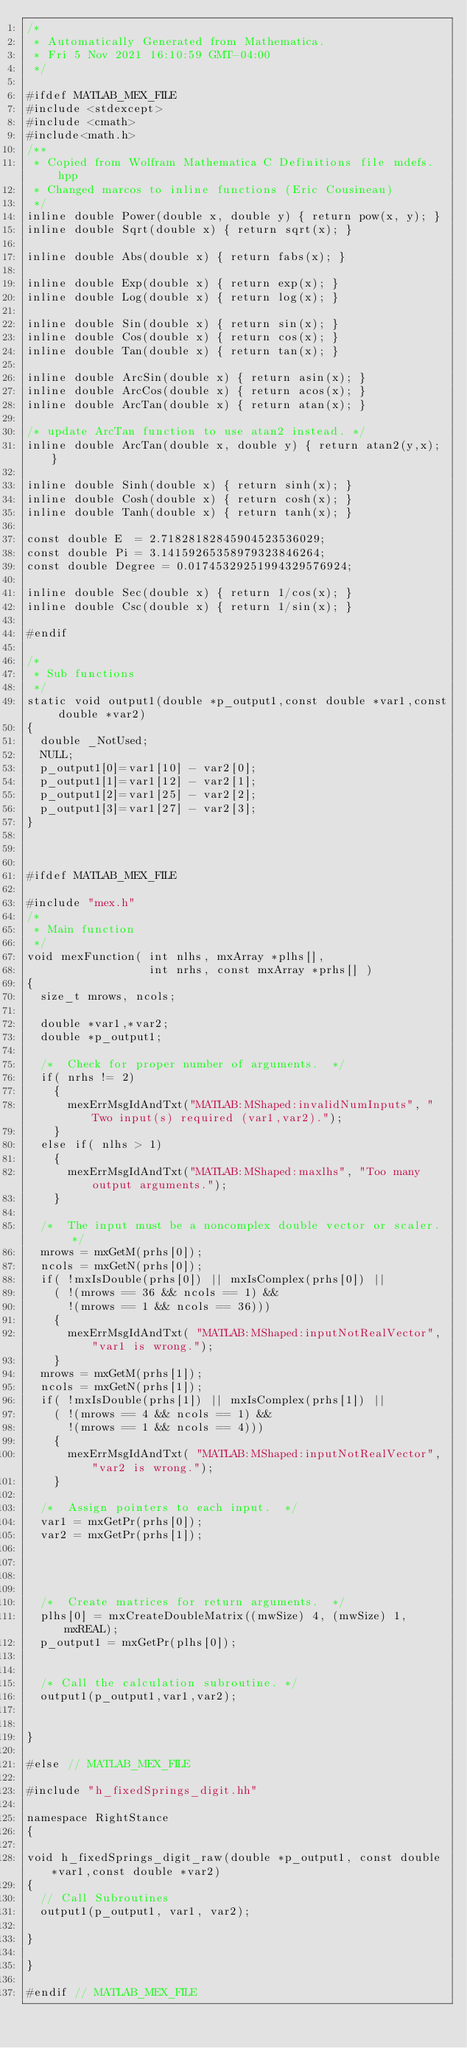<code> <loc_0><loc_0><loc_500><loc_500><_C++_>/*
 * Automatically Generated from Mathematica.
 * Fri 5 Nov 2021 16:10:59 GMT-04:00
 */

#ifdef MATLAB_MEX_FILE
#include <stdexcept>
#include <cmath>
#include<math.h>
/**
 * Copied from Wolfram Mathematica C Definitions file mdefs.hpp
 * Changed marcos to inline functions (Eric Cousineau)
 */
inline double Power(double x, double y) { return pow(x, y); }
inline double Sqrt(double x) { return sqrt(x); }

inline double Abs(double x) { return fabs(x); }

inline double Exp(double x) { return exp(x); }
inline double Log(double x) { return log(x); }

inline double Sin(double x) { return sin(x); }
inline double Cos(double x) { return cos(x); }
inline double Tan(double x) { return tan(x); }

inline double ArcSin(double x) { return asin(x); }
inline double ArcCos(double x) { return acos(x); }
inline double ArcTan(double x) { return atan(x); }

/* update ArcTan function to use atan2 instead. */
inline double ArcTan(double x, double y) { return atan2(y,x); }

inline double Sinh(double x) { return sinh(x); }
inline double Cosh(double x) { return cosh(x); }
inline double Tanh(double x) { return tanh(x); }

const double E	= 2.71828182845904523536029;
const double Pi = 3.14159265358979323846264;
const double Degree = 0.01745329251994329576924;

inline double Sec(double x) { return 1/cos(x); }
inline double Csc(double x) { return 1/sin(x); }

#endif

/*
 * Sub functions
 */
static void output1(double *p_output1,const double *var1,const double *var2)
{
  double _NotUsed;
  NULL;
  p_output1[0]=var1[10] - var2[0];
  p_output1[1]=var1[12] - var2[1];
  p_output1[2]=var1[25] - var2[2];
  p_output1[3]=var1[27] - var2[3];
}



#ifdef MATLAB_MEX_FILE

#include "mex.h"
/*
 * Main function
 */
void mexFunction( int nlhs, mxArray *plhs[],
                  int nrhs, const mxArray *prhs[] )
{
  size_t mrows, ncols;

  double *var1,*var2;
  double *p_output1;

  /*  Check for proper number of arguments.  */ 
  if( nrhs != 2)
    {
      mexErrMsgIdAndTxt("MATLAB:MShaped:invalidNumInputs", "Two input(s) required (var1,var2).");
    }
  else if( nlhs > 1)
    {
      mexErrMsgIdAndTxt("MATLAB:MShaped:maxlhs", "Too many output arguments.");
    }

  /*  The input must be a noncomplex double vector or scaler.  */
  mrows = mxGetM(prhs[0]);
  ncols = mxGetN(prhs[0]);
  if( !mxIsDouble(prhs[0]) || mxIsComplex(prhs[0]) ||
    ( !(mrows == 36 && ncols == 1) && 
      !(mrows == 1 && ncols == 36))) 
    {
      mexErrMsgIdAndTxt( "MATLAB:MShaped:inputNotRealVector", "var1 is wrong.");
    }
  mrows = mxGetM(prhs[1]);
  ncols = mxGetN(prhs[1]);
  if( !mxIsDouble(prhs[1]) || mxIsComplex(prhs[1]) ||
    ( !(mrows == 4 && ncols == 1) && 
      !(mrows == 1 && ncols == 4))) 
    {
      mexErrMsgIdAndTxt( "MATLAB:MShaped:inputNotRealVector", "var2 is wrong.");
    }

  /*  Assign pointers to each input.  */
  var1 = mxGetPr(prhs[0]);
  var2 = mxGetPr(prhs[1]);
   


   
  /*  Create matrices for return arguments.  */
  plhs[0] = mxCreateDoubleMatrix((mwSize) 4, (mwSize) 1, mxREAL);
  p_output1 = mxGetPr(plhs[0]);


  /* Call the calculation subroutine. */
  output1(p_output1,var1,var2);


}

#else // MATLAB_MEX_FILE

#include "h_fixedSprings_digit.hh"

namespace RightStance
{

void h_fixedSprings_digit_raw(double *p_output1, const double *var1,const double *var2)
{
  // Call Subroutines
  output1(p_output1, var1, var2);

}

}

#endif // MATLAB_MEX_FILE
</code> 